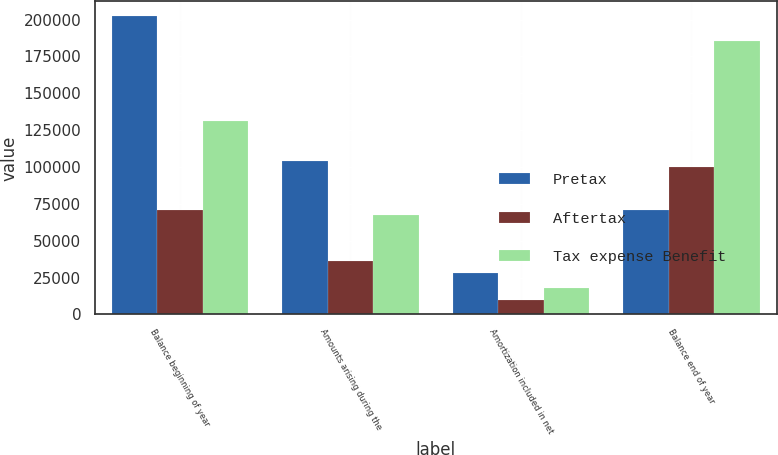Convert chart. <chart><loc_0><loc_0><loc_500><loc_500><stacked_bar_chart><ecel><fcel>Balance beginning of year<fcel>Amounts arising during the<fcel>Amortization included in net<fcel>Balance end of year<nl><fcel>Pretax<fcel>202292<fcel>104146<fcel>28077<fcel>70803<nl><fcel>Aftertax<fcel>70803<fcel>36451<fcel>9827<fcel>99813<nl><fcel>Tax expense Benefit<fcel>131489<fcel>67695<fcel>18250<fcel>185364<nl></chart> 